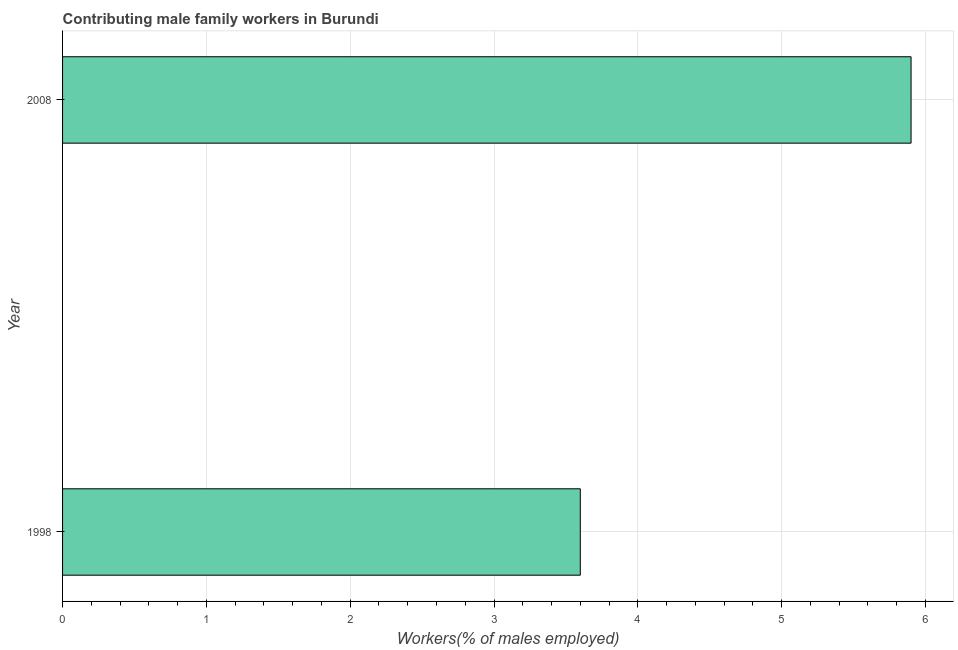What is the title of the graph?
Ensure brevity in your answer.  Contributing male family workers in Burundi. What is the label or title of the X-axis?
Keep it short and to the point. Workers(% of males employed). What is the label or title of the Y-axis?
Keep it short and to the point. Year. What is the contributing male family workers in 2008?
Give a very brief answer. 5.9. Across all years, what is the maximum contributing male family workers?
Make the answer very short. 5.9. Across all years, what is the minimum contributing male family workers?
Keep it short and to the point. 3.6. In which year was the contributing male family workers minimum?
Give a very brief answer. 1998. What is the average contributing male family workers per year?
Your response must be concise. 4.75. What is the median contributing male family workers?
Provide a short and direct response. 4.75. What is the ratio of the contributing male family workers in 1998 to that in 2008?
Provide a short and direct response. 0.61. In how many years, is the contributing male family workers greater than the average contributing male family workers taken over all years?
Keep it short and to the point. 1. What is the difference between two consecutive major ticks on the X-axis?
Provide a short and direct response. 1. Are the values on the major ticks of X-axis written in scientific E-notation?
Your answer should be very brief. No. What is the Workers(% of males employed) of 1998?
Provide a succinct answer. 3.6. What is the Workers(% of males employed) of 2008?
Your answer should be very brief. 5.9. What is the ratio of the Workers(% of males employed) in 1998 to that in 2008?
Offer a terse response. 0.61. 